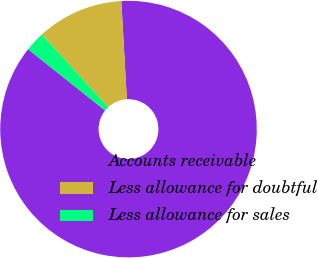<chart> <loc_0><loc_0><loc_500><loc_500><pie_chart><fcel>Accounts receivable<fcel>Less allowance for doubtful<fcel>Less allowance for sales<nl><fcel>86.59%<fcel>10.91%<fcel>2.5%<nl></chart> 